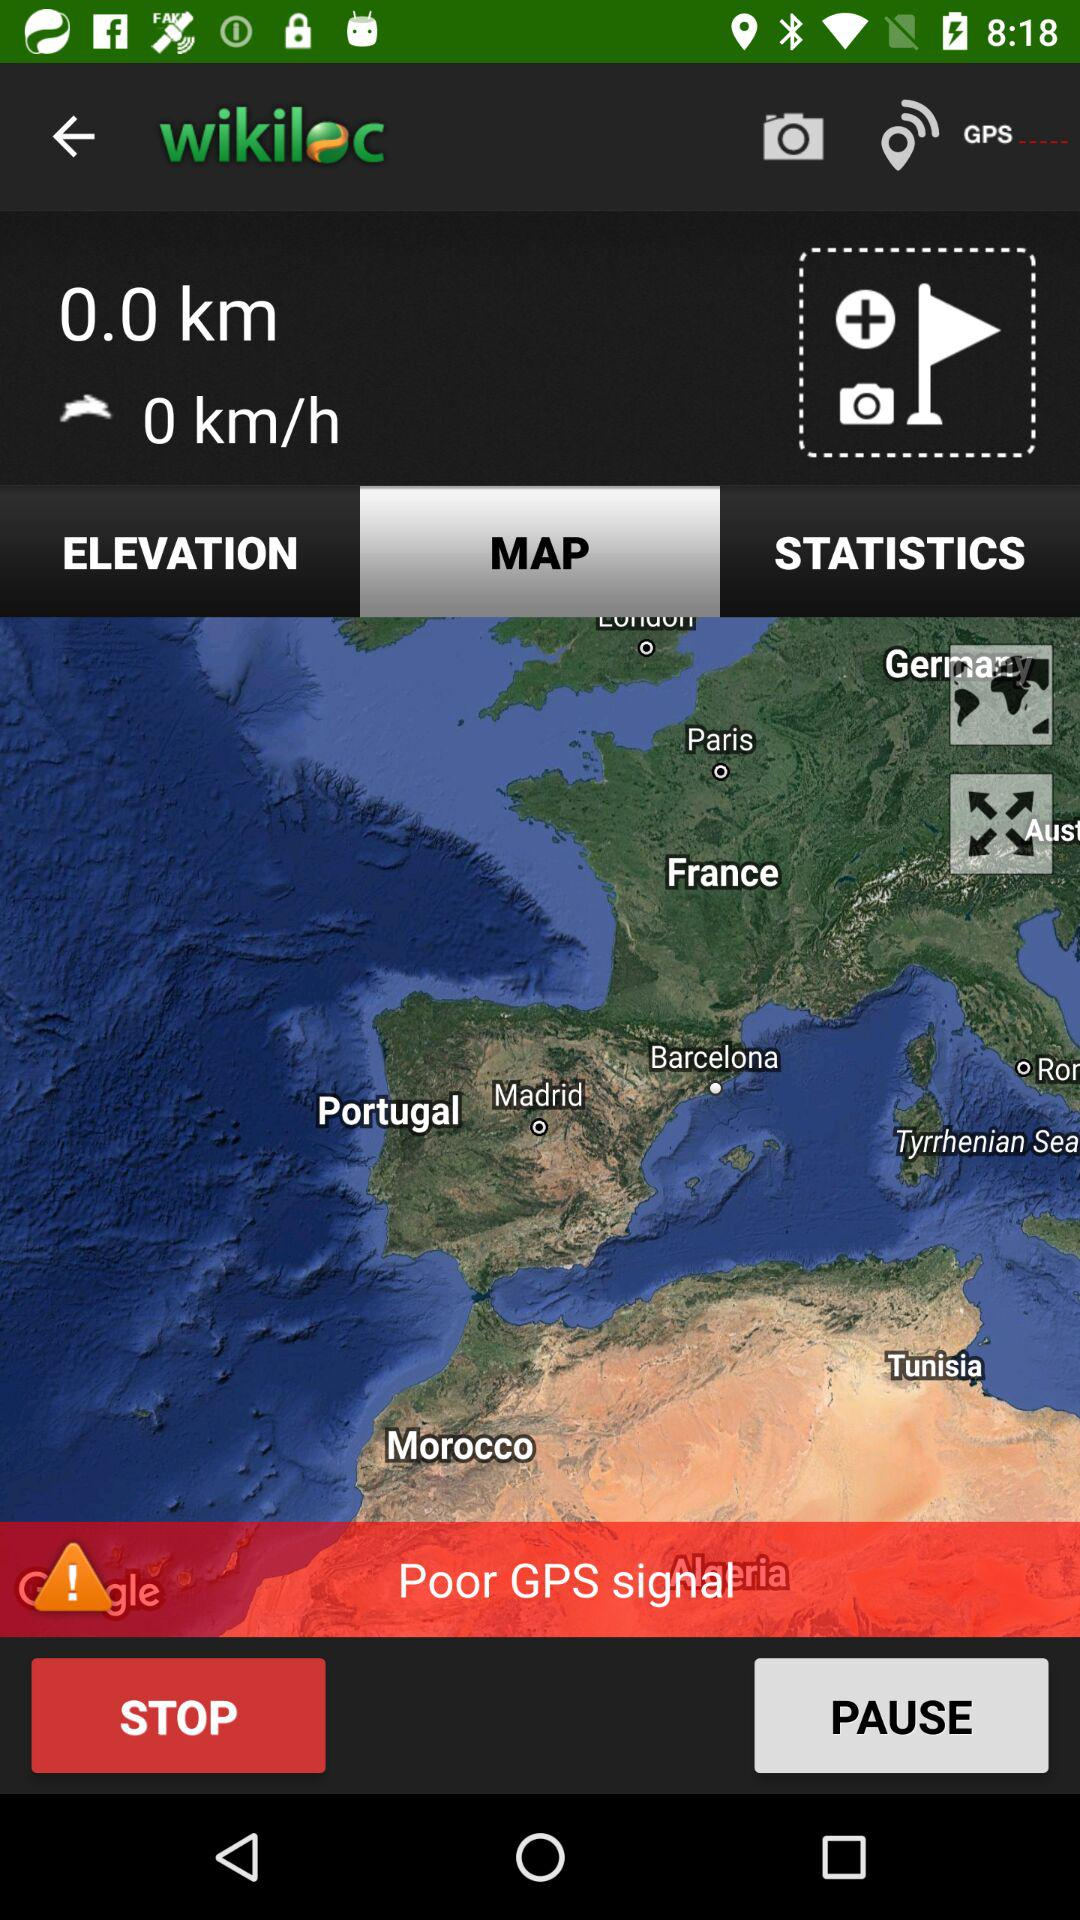What's the total number of Km? It is 0 km. 